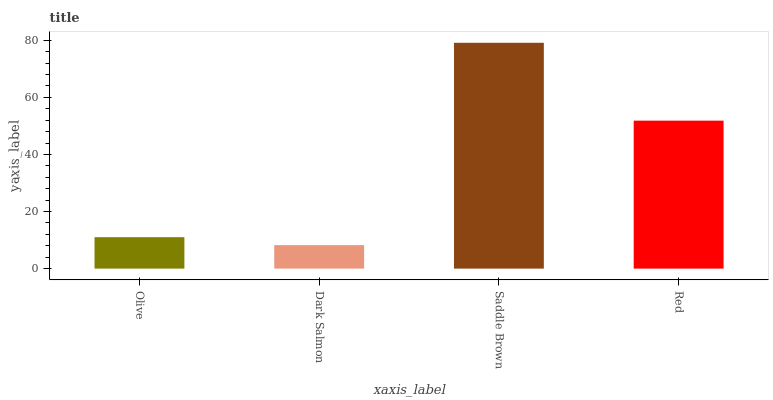Is Dark Salmon the minimum?
Answer yes or no. Yes. Is Saddle Brown the maximum?
Answer yes or no. Yes. Is Saddle Brown the minimum?
Answer yes or no. No. Is Dark Salmon the maximum?
Answer yes or no. No. Is Saddle Brown greater than Dark Salmon?
Answer yes or no. Yes. Is Dark Salmon less than Saddle Brown?
Answer yes or no. Yes. Is Dark Salmon greater than Saddle Brown?
Answer yes or no. No. Is Saddle Brown less than Dark Salmon?
Answer yes or no. No. Is Red the high median?
Answer yes or no. Yes. Is Olive the low median?
Answer yes or no. Yes. Is Saddle Brown the high median?
Answer yes or no. No. Is Red the low median?
Answer yes or no. No. 